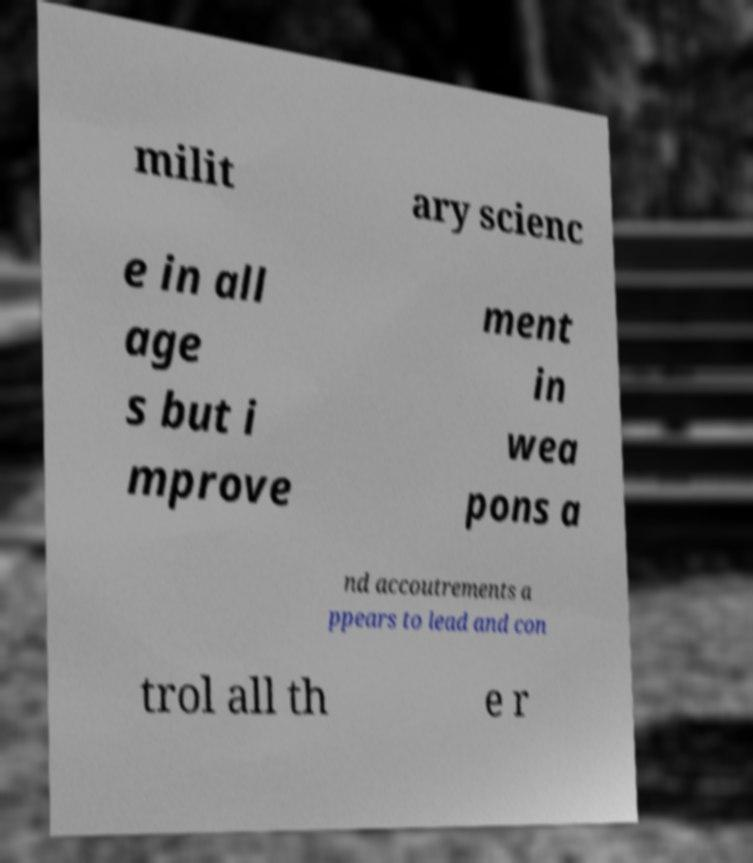For documentation purposes, I need the text within this image transcribed. Could you provide that? milit ary scienc e in all age s but i mprove ment in wea pons a nd accoutrements a ppears to lead and con trol all th e r 